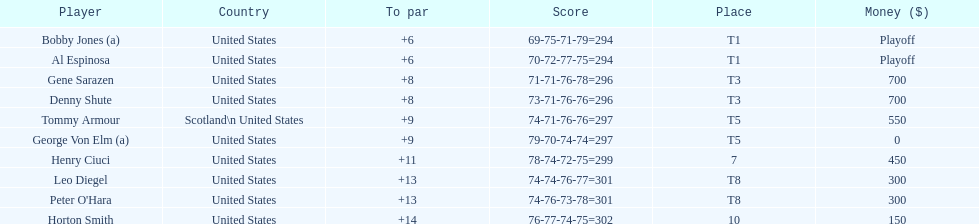What was al espinosa's total stroke count at the final of the 1929 us open? 294. 